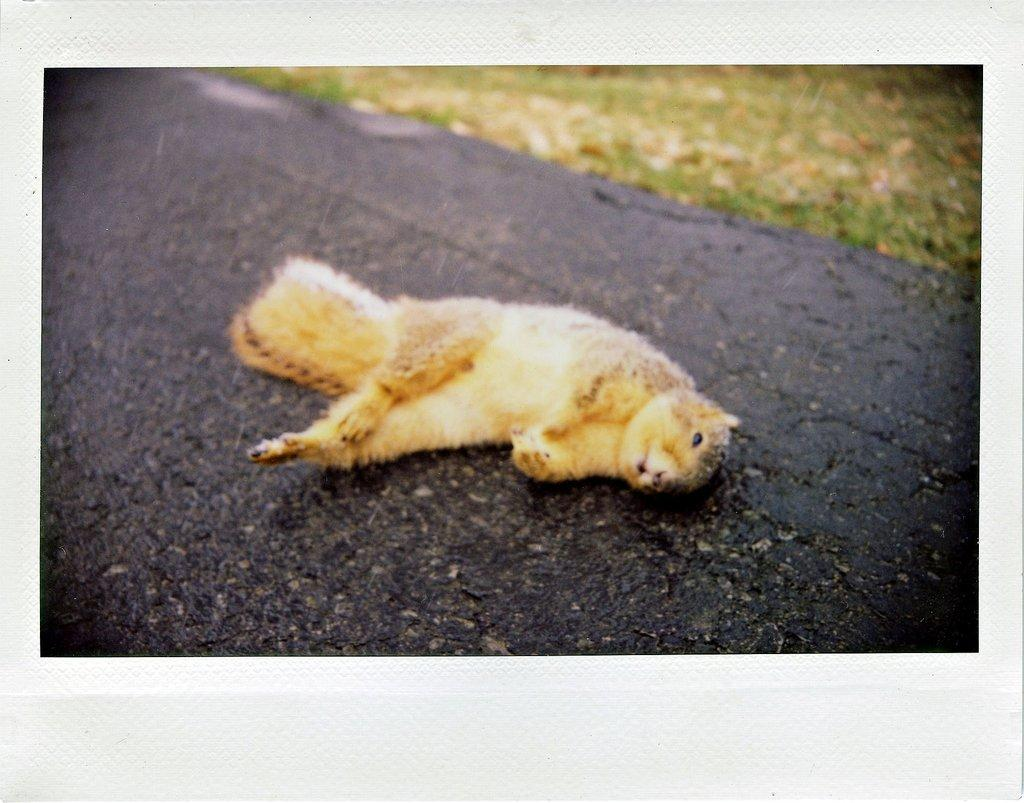What animal can be seen in the image? There is a squirrel in the image. Where is the squirrel located? The squirrel is lying on the road. What type of vegetation is visible near the road? There is grass beside the road in the image. What type of icicle can be seen hanging from the squirrel's tail in the image? There is no icicle present in the image, as the squirrel is lying on the road and not in a cold environment where icicles would form. 